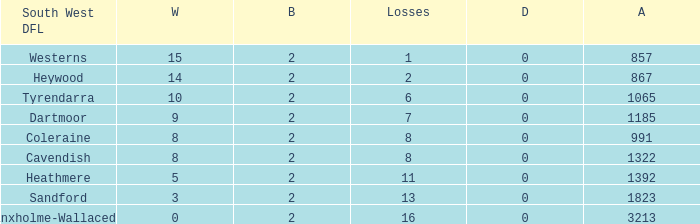Which draws have an average of 14 wins? 0.0. Can you parse all the data within this table? {'header': ['South West DFL', 'W', 'B', 'Losses', 'D', 'A'], 'rows': [['Westerns', '15', '2', '1', '0', '857'], ['Heywood', '14', '2', '2', '0', '867'], ['Tyrendarra', '10', '2', '6', '0', '1065'], ['Dartmoor', '9', '2', '7', '0', '1185'], ['Coleraine', '8', '2', '8', '0', '991'], ['Cavendish', '8', '2', '8', '0', '1322'], ['Heathmere', '5', '2', '11', '0', '1392'], ['Sandford', '3', '2', '13', '0', '1823'], ['Branxholme-Wallacedale', '0', '2', '16', '0', '3213']]} 